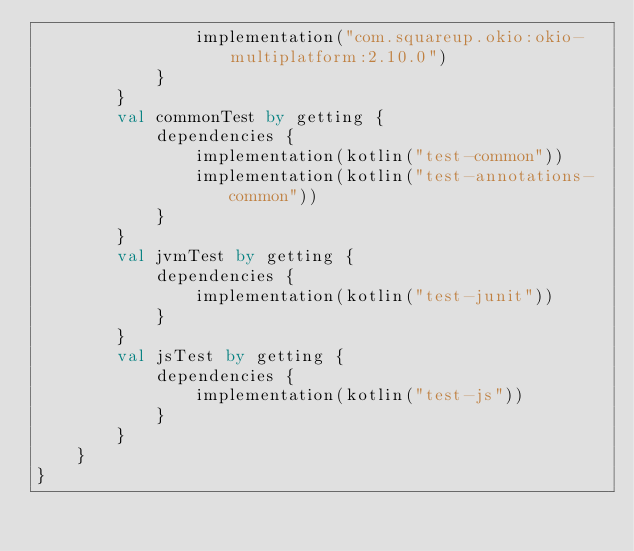<code> <loc_0><loc_0><loc_500><loc_500><_Kotlin_>                implementation("com.squareup.okio:okio-multiplatform:2.10.0")
            }
        }
        val commonTest by getting {
            dependencies {
                implementation(kotlin("test-common"))
                implementation(kotlin("test-annotations-common"))
            }
        }
        val jvmTest by getting {
            dependencies {
                implementation(kotlin("test-junit"))
            }
        }
        val jsTest by getting {
            dependencies {
                implementation(kotlin("test-js"))
            }
        }
    }
}</code> 